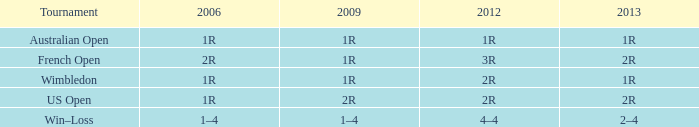Could you parse the entire table as a dict? {'header': ['Tournament', '2006', '2009', '2012', '2013'], 'rows': [['Australian Open', '1R', '1R', '1R', '1R'], ['French Open', '2R', '1R', '3R', '2R'], ['Wimbledon', '1R', '1R', '2R', '1R'], ['US Open', '1R', '2R', '2R', '2R'], ['Win–Loss', '1–4', '1–4', '4–4', '2–4']]} What is the 2006 when the 2013 is 2r, and a Tournament was the us open? 1R. 